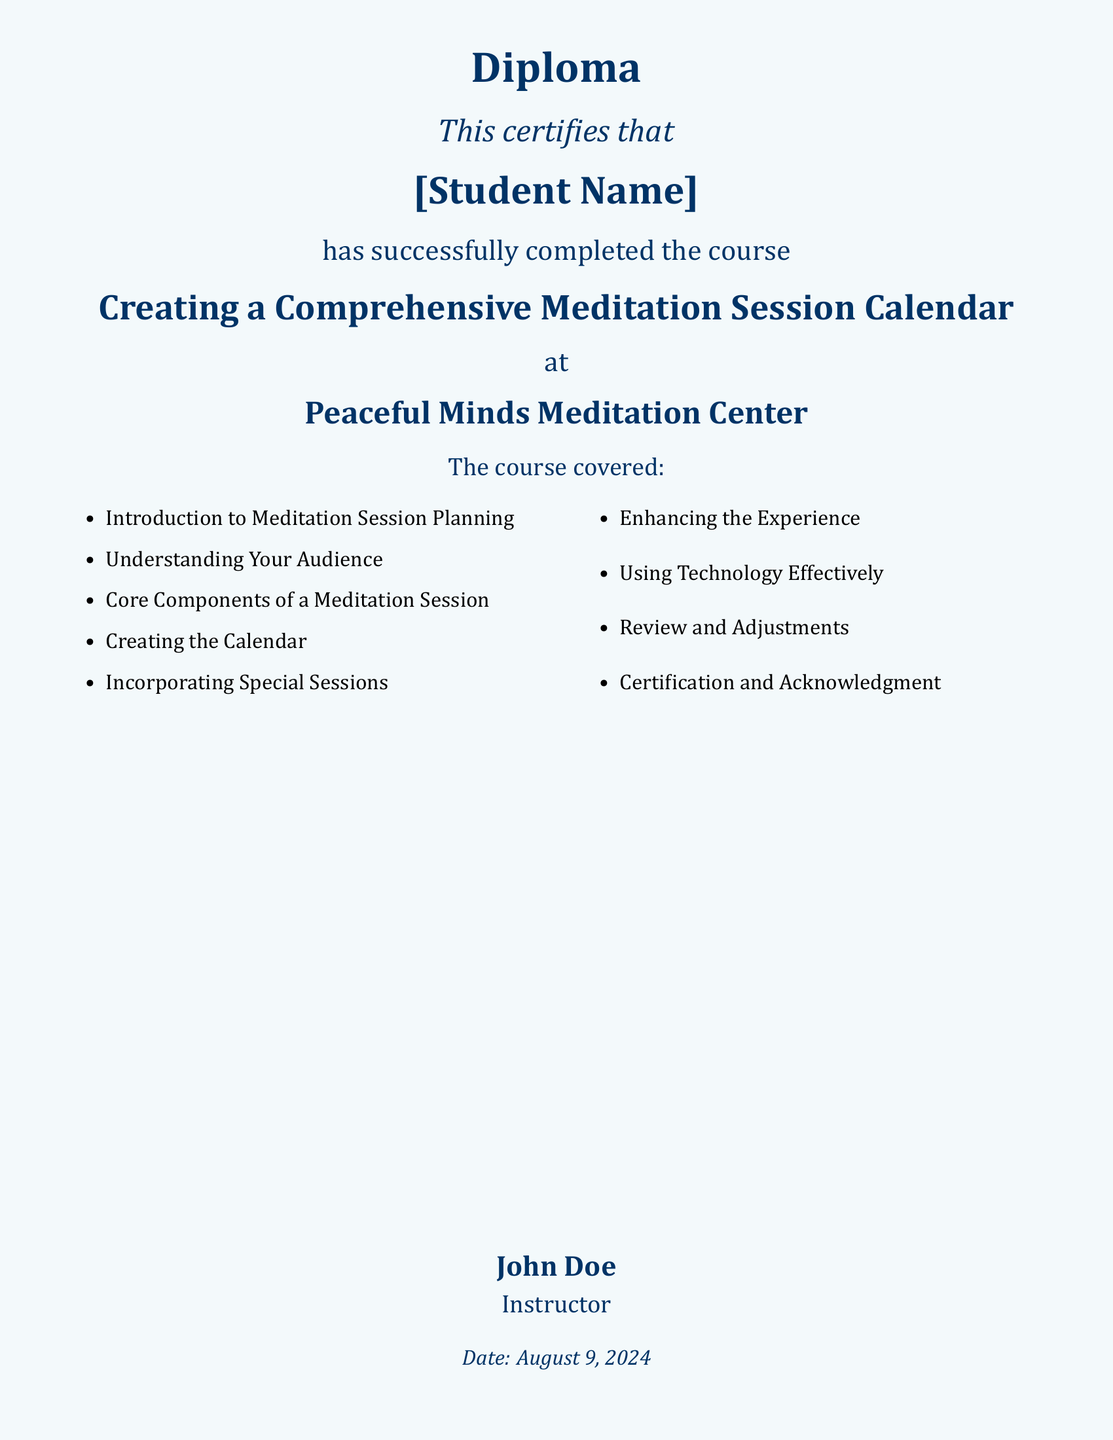What is the title of the course completed? The title of the course is stated prominently in the document as "Creating a Comprehensive Meditation Session Calendar."
Answer: Creating a Comprehensive Meditation Session Calendar Who is the instructor listed on the diploma? The instructor's name is clearly mentioned at the bottom of the document as "John Doe."
Answer: John Doe What is the name of the meditation center? The name of the center where the course was completed is mentioned as "Peaceful Minds Meditation Center."
Answer: Peaceful Minds Meditation Center How many core components are listed in the course? The number of core components is indicated in the bulleted list within the document, which contains nine items.
Answer: 9 What color is the page background? The document specifies a color for the page background, described in the code as "calmblue."
Answer: calmblue Which item appears last in the list of course topics? The last item listed in the bulleted course topics is "Certification and Acknowledgment."
Answer: Certification and Acknowledgment What date is mentioned in the diploma? The date is indicated by the command "\today," which renders the current date when the document is generated.
Answer: today's date What font is specified as the main font? The main font chosen for the document is explicitly defined as "Cambria."
Answer: Cambria 